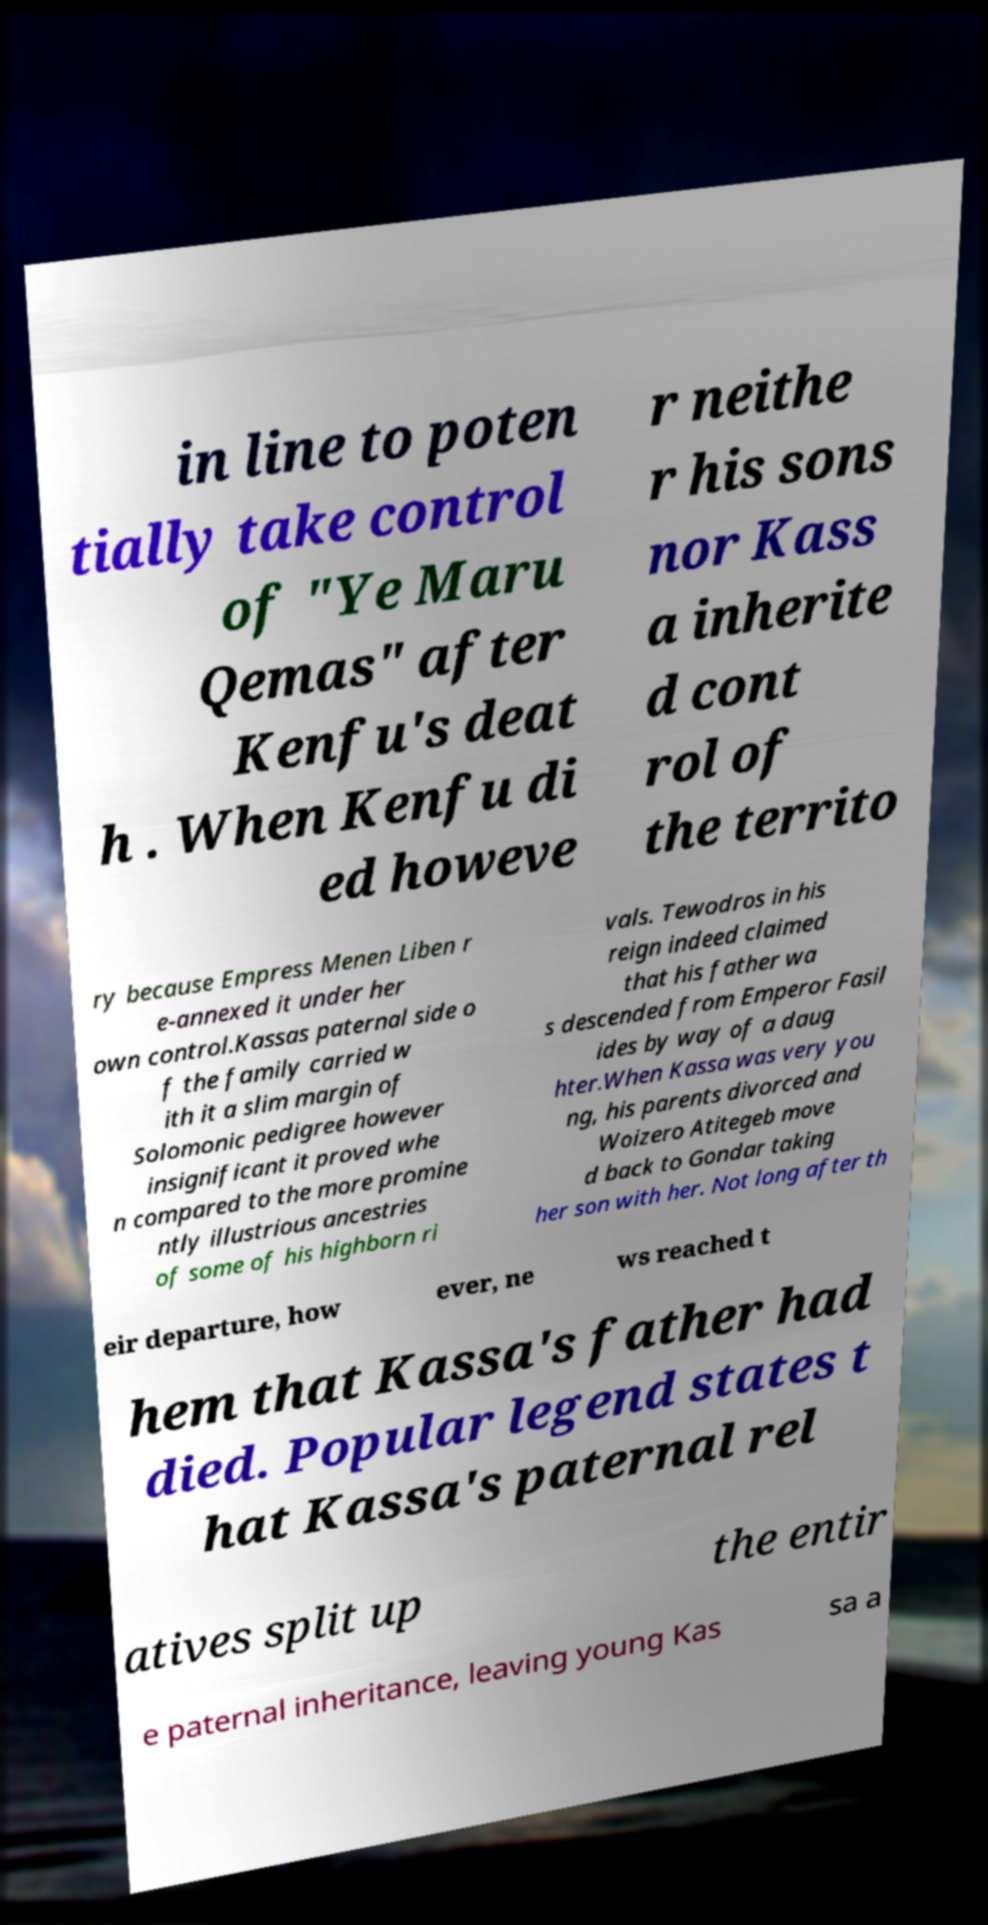For documentation purposes, I need the text within this image transcribed. Could you provide that? in line to poten tially take control of "Ye Maru Qemas" after Kenfu's deat h . When Kenfu di ed howeve r neithe r his sons nor Kass a inherite d cont rol of the territo ry because Empress Menen Liben r e-annexed it under her own control.Kassas paternal side o f the family carried w ith it a slim margin of Solomonic pedigree however insignificant it proved whe n compared to the more promine ntly illustrious ancestries of some of his highborn ri vals. Tewodros in his reign indeed claimed that his father wa s descended from Emperor Fasil ides by way of a daug hter.When Kassa was very you ng, his parents divorced and Woizero Atitegeb move d back to Gondar taking her son with her. Not long after th eir departure, how ever, ne ws reached t hem that Kassa's father had died. Popular legend states t hat Kassa's paternal rel atives split up the entir e paternal inheritance, leaving young Kas sa a 